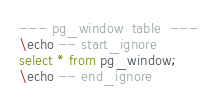Convert code to text. <code><loc_0><loc_0><loc_500><loc_500><_SQL_>--- pg_window  table  ---
\echo -- start_ignore
select * from pg_window;
\echo -- end_ignore
</code> 